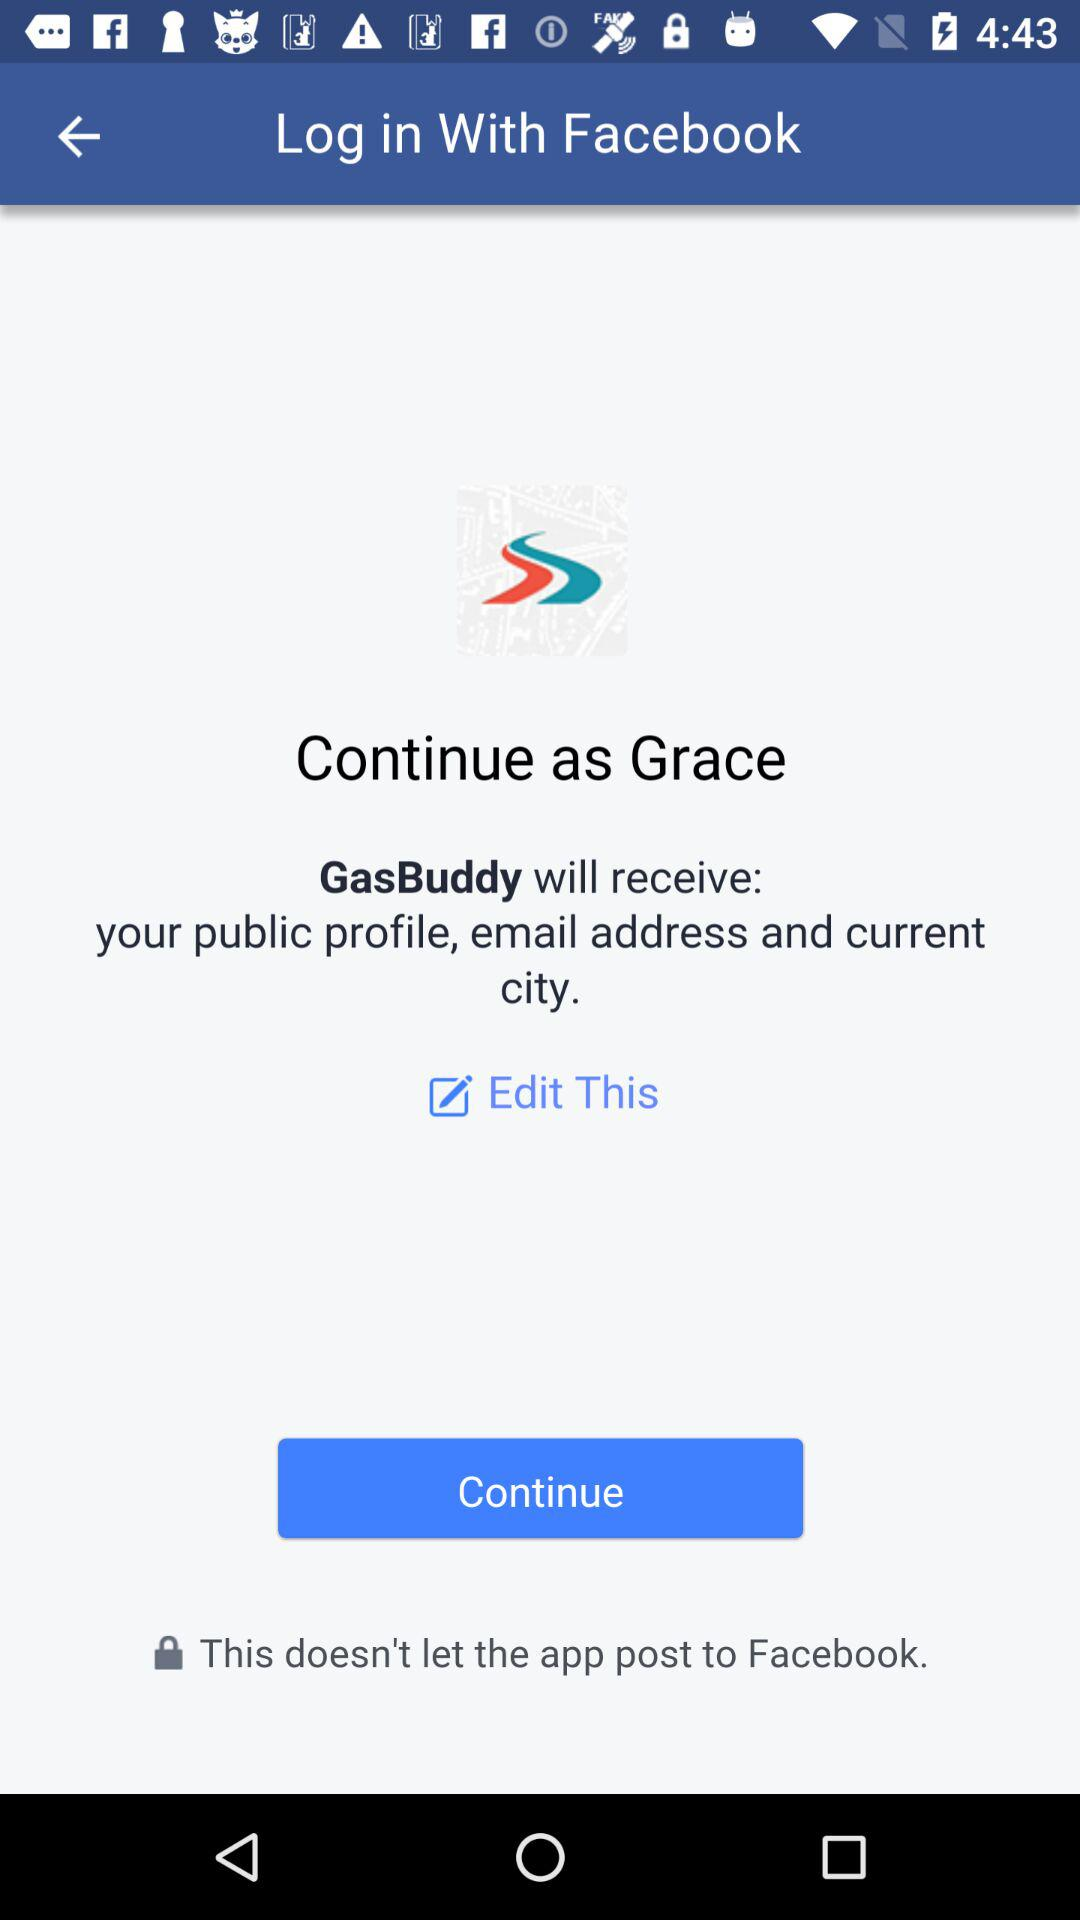Through what application can we log in? You can log in through "Facebook". 